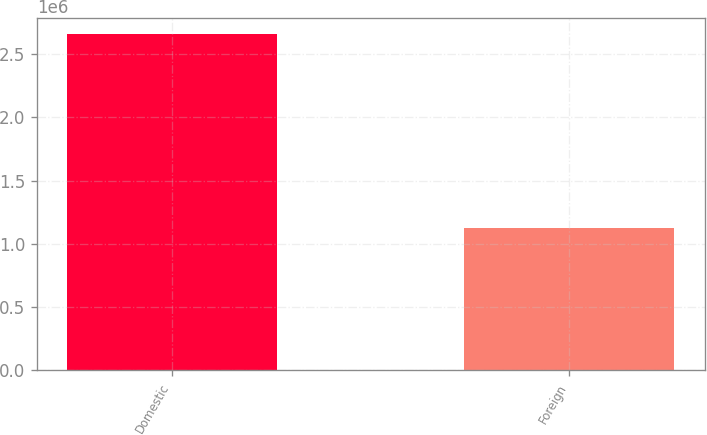Convert chart to OTSL. <chart><loc_0><loc_0><loc_500><loc_500><bar_chart><fcel>Domestic<fcel>Foreign<nl><fcel>2.65544e+06<fcel>1.12153e+06<nl></chart> 